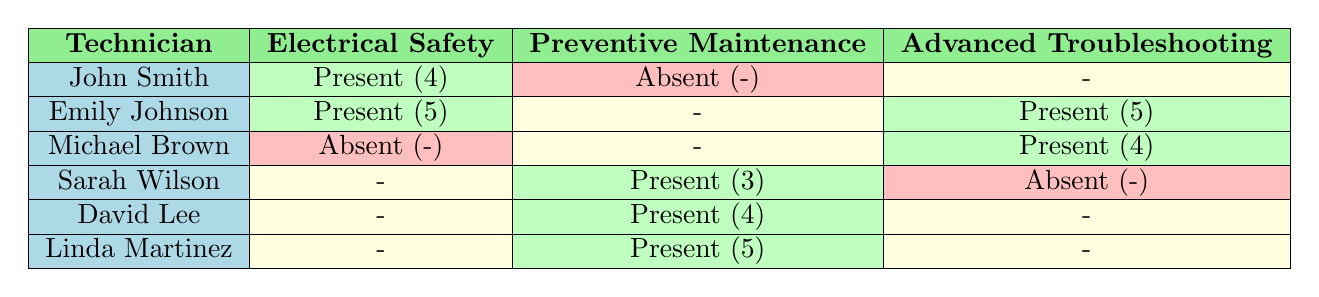What was John Smith's feedback rating for the Electrical Safety Training? John Smith's feedback rating for the Electrical Safety Training is located in the table under the "Electrical Safety" column where his attendance is marked as Present. The feedback rating next to it is 4.
Answer: 4 How many sessions did Michael Brown attend? To find the number of sessions Michael Brown attended, we look at each training session listed. He is marked as Present in one session (Advanced Troubleshooting) and Absent in two sessions (Electrical Safety and Preventive Maintenance). Therefore, he attended 1 session.
Answer: 1 Did Sarah Wilson attend all the training sessions? To determine if Sarah Wilson attended all the training sessions, we can check her attendance across the sessions. She was Present in one session (Preventive Maintenance Techniques) and Absent in two sessions (Electrical Safety and Advanced Troubleshooting). This shows that she did not attend all sessions.
Answer: No What is the average feedback rating for the session on Advanced Troubleshooting Techniques? For the Advanced Troubleshooting session, we have two feedback ratings: Emily Johnson with a rating of 5 and Michael Brown with a rating of 4. We sum these ratings (5 + 4 = 9) and then divide by the number of attendees (2). Thus, the average rating is 9 / 2 = 4.5.
Answer: 4.5 Which session had the highest feedback rating from attendees? To find the session with the highest feedback rating, we must compare the ratings for each session. The ratings are as follows: Electrical Safety - 4 (John Smith) and 5 (Emily Johnson); Preventive Maintenance - 3 (Sarah Wilson), 4 (David Lee), and 5 (Linda Martinez); Advanced Troubleshooting - 5 (Emily Johnson) and 4 (Michael Brown). The highest rating observed is 5 from the Electrical Safety session and the Preventive Maintenance session, indicating both of these sessions had the highest individual feedback ratings.
Answer: Electrical Safety and Preventive Maintenance How many technicians were present for the Preventive Maintenance Techniques session? In the table for the Preventive Maintenance Techniques session, we see three technicians marked as Present: Sarah Wilson, David Lee, and Linda Martinez. Counting them gives us a total of 3 technicians who attended.
Answer: 3 